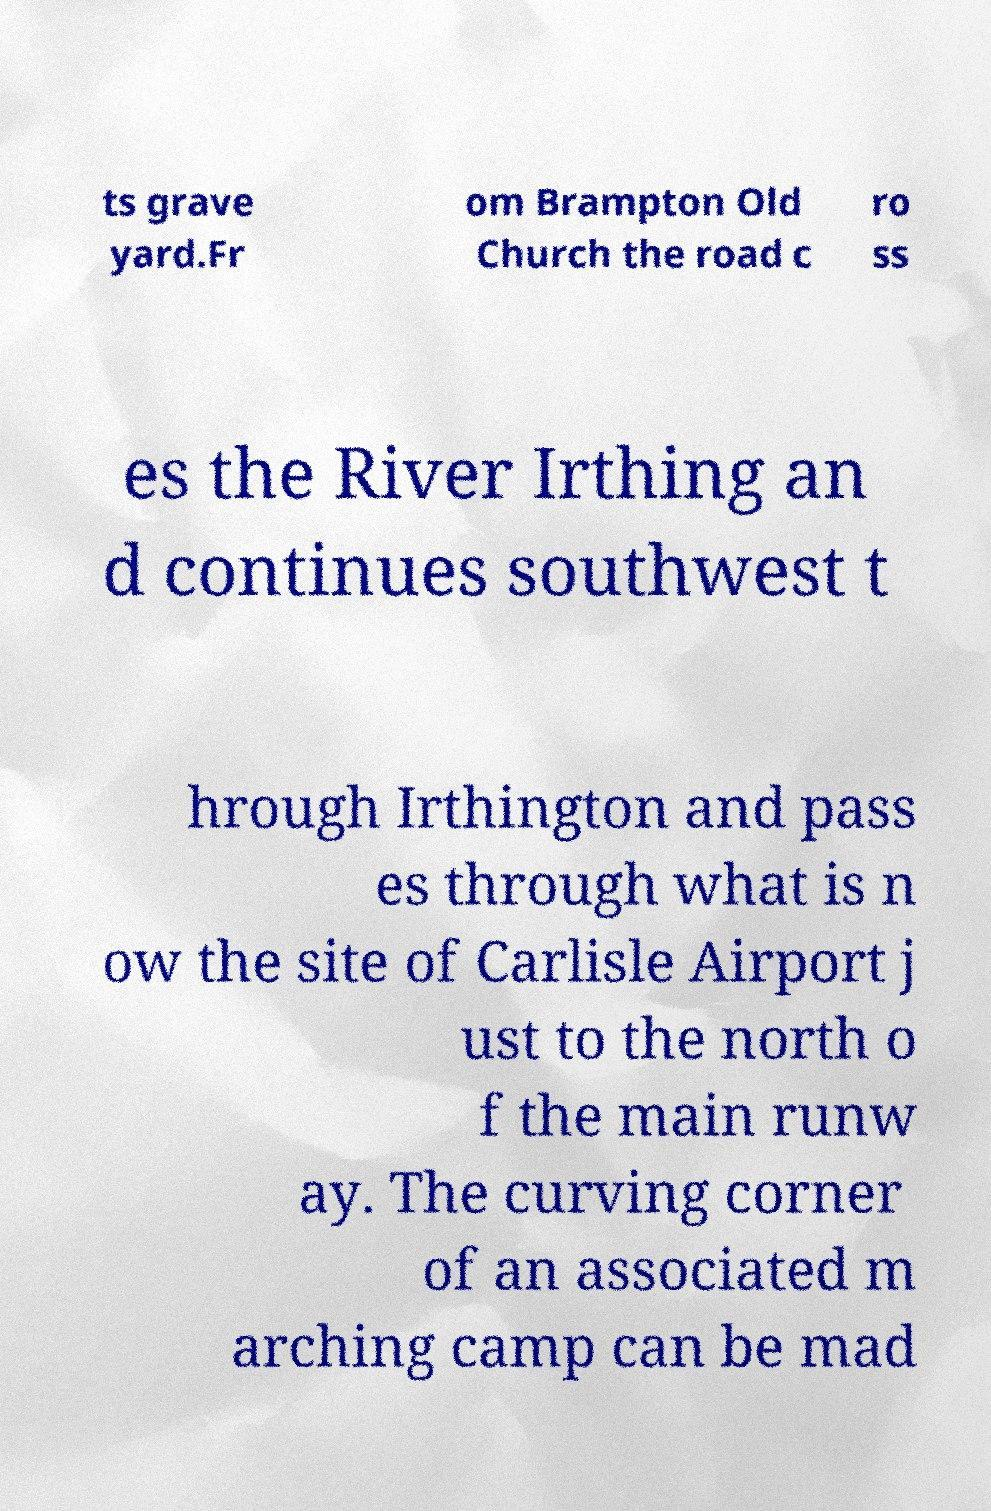Can you accurately transcribe the text from the provided image for me? ts grave yard.Fr om Brampton Old Church the road c ro ss es the River Irthing an d continues southwest t hrough Irthington and pass es through what is n ow the site of Carlisle Airport j ust to the north o f the main runw ay. The curving corner of an associated m arching camp can be mad 